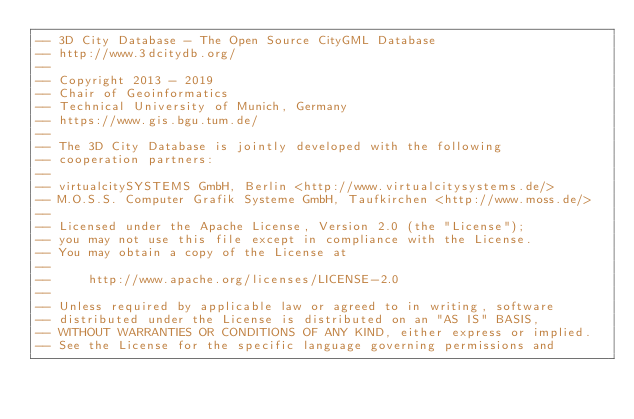Convert code to text. <code><loc_0><loc_0><loc_500><loc_500><_SQL_>-- 3D City Database - The Open Source CityGML Database
-- http://www.3dcitydb.org/
-- 
-- Copyright 2013 - 2019
-- Chair of Geoinformatics
-- Technical University of Munich, Germany
-- https://www.gis.bgu.tum.de/
-- 
-- The 3D City Database is jointly developed with the following
-- cooperation partners:
-- 
-- virtualcitySYSTEMS GmbH, Berlin <http://www.virtualcitysystems.de/>
-- M.O.S.S. Computer Grafik Systeme GmbH, Taufkirchen <http://www.moss.de/>
-- 
-- Licensed under the Apache License, Version 2.0 (the "License");
-- you may not use this file except in compliance with the License.
-- You may obtain a copy of the License at
-- 
--     http://www.apache.org/licenses/LICENSE-2.0
--     
-- Unless required by applicable law or agreed to in writing, software
-- distributed under the License is distributed on an "AS IS" BASIS,
-- WITHOUT WARRANTIES OR CONDITIONS OF ANY KIND, either express or implied.
-- See the License for the specific language governing permissions and</code> 